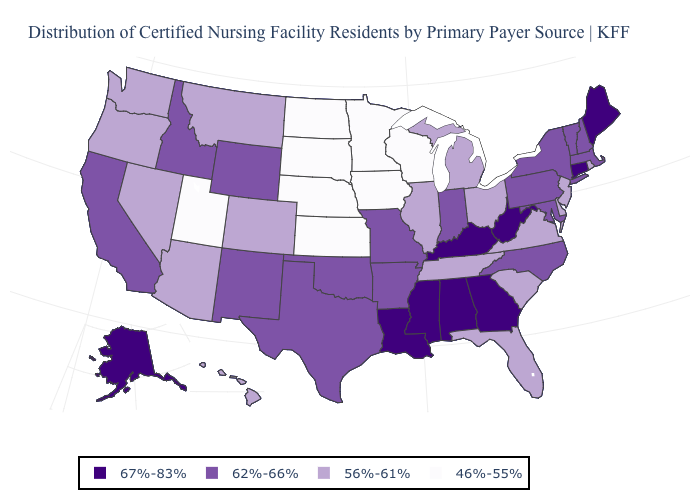Name the states that have a value in the range 56%-61%?
Write a very short answer. Arizona, Colorado, Delaware, Florida, Hawaii, Illinois, Michigan, Montana, Nevada, New Jersey, Ohio, Oregon, Rhode Island, South Carolina, Tennessee, Virginia, Washington. What is the value of North Carolina?
Short answer required. 62%-66%. Name the states that have a value in the range 56%-61%?
Be succinct. Arizona, Colorado, Delaware, Florida, Hawaii, Illinois, Michigan, Montana, Nevada, New Jersey, Ohio, Oregon, Rhode Island, South Carolina, Tennessee, Virginia, Washington. What is the lowest value in states that border California?
Give a very brief answer. 56%-61%. Does Montana have the same value as New Jersey?
Quick response, please. Yes. Name the states that have a value in the range 67%-83%?
Give a very brief answer. Alabama, Alaska, Connecticut, Georgia, Kentucky, Louisiana, Maine, Mississippi, West Virginia. Which states have the lowest value in the USA?
Answer briefly. Iowa, Kansas, Minnesota, Nebraska, North Dakota, South Dakota, Utah, Wisconsin. What is the lowest value in the South?
Answer briefly. 56%-61%. Name the states that have a value in the range 46%-55%?
Be succinct. Iowa, Kansas, Minnesota, Nebraska, North Dakota, South Dakota, Utah, Wisconsin. Which states have the highest value in the USA?
Answer briefly. Alabama, Alaska, Connecticut, Georgia, Kentucky, Louisiana, Maine, Mississippi, West Virginia. Does Alabama have the lowest value in the South?
Write a very short answer. No. What is the lowest value in the USA?
Write a very short answer. 46%-55%. Name the states that have a value in the range 46%-55%?
Short answer required. Iowa, Kansas, Minnesota, Nebraska, North Dakota, South Dakota, Utah, Wisconsin. Name the states that have a value in the range 67%-83%?
Short answer required. Alabama, Alaska, Connecticut, Georgia, Kentucky, Louisiana, Maine, Mississippi, West Virginia. 